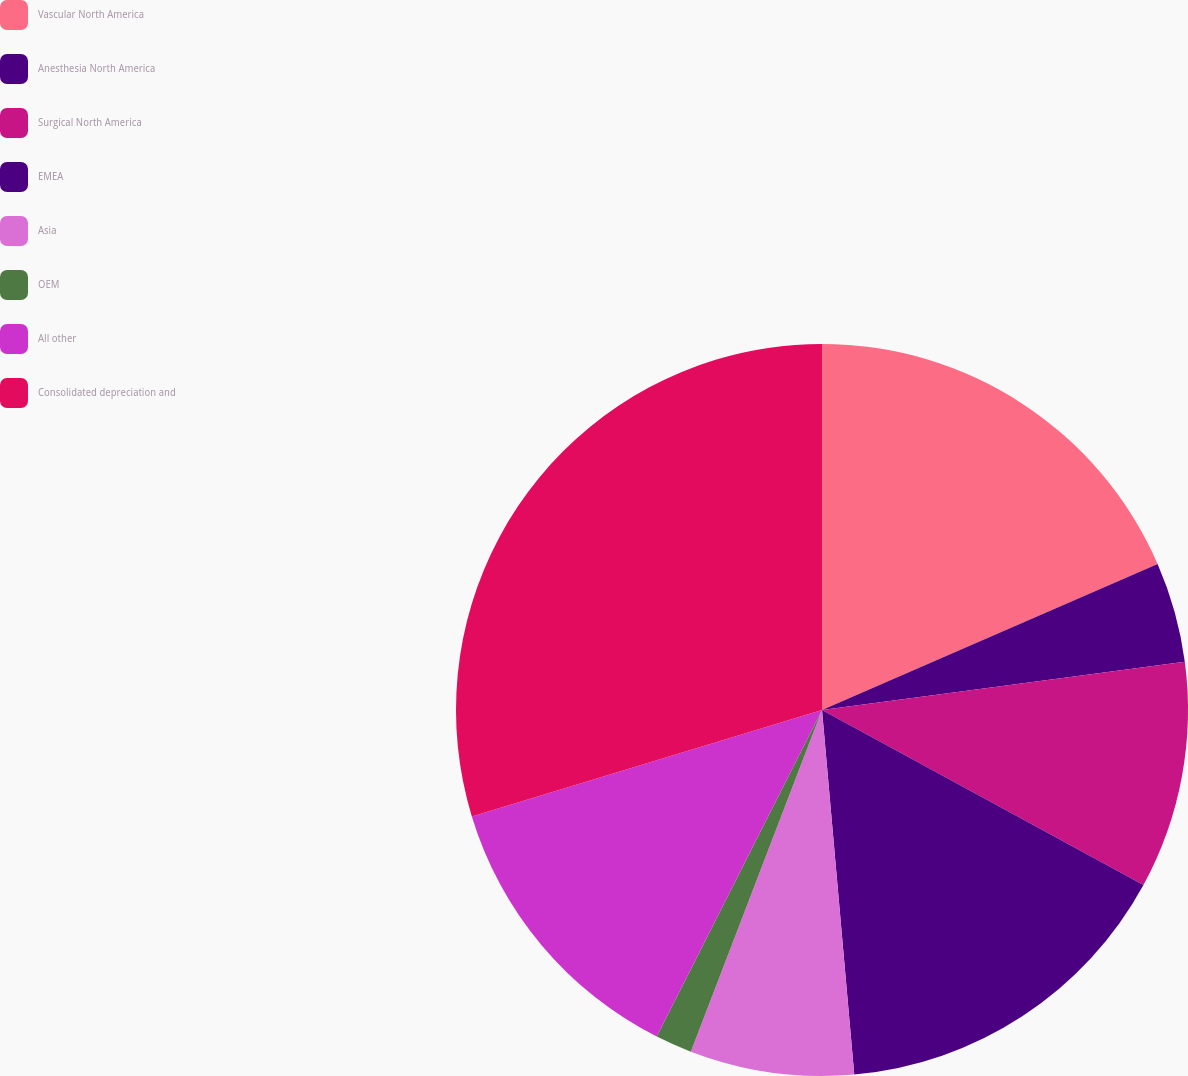Convert chart. <chart><loc_0><loc_0><loc_500><loc_500><pie_chart><fcel>Vascular North America<fcel>Anesthesia North America<fcel>Surgical North America<fcel>EMEA<fcel>Asia<fcel>OEM<fcel>All other<fcel>Consolidated depreciation and<nl><fcel>18.47%<fcel>4.43%<fcel>10.04%<fcel>15.66%<fcel>7.24%<fcel>1.62%<fcel>12.85%<fcel>29.7%<nl></chart> 